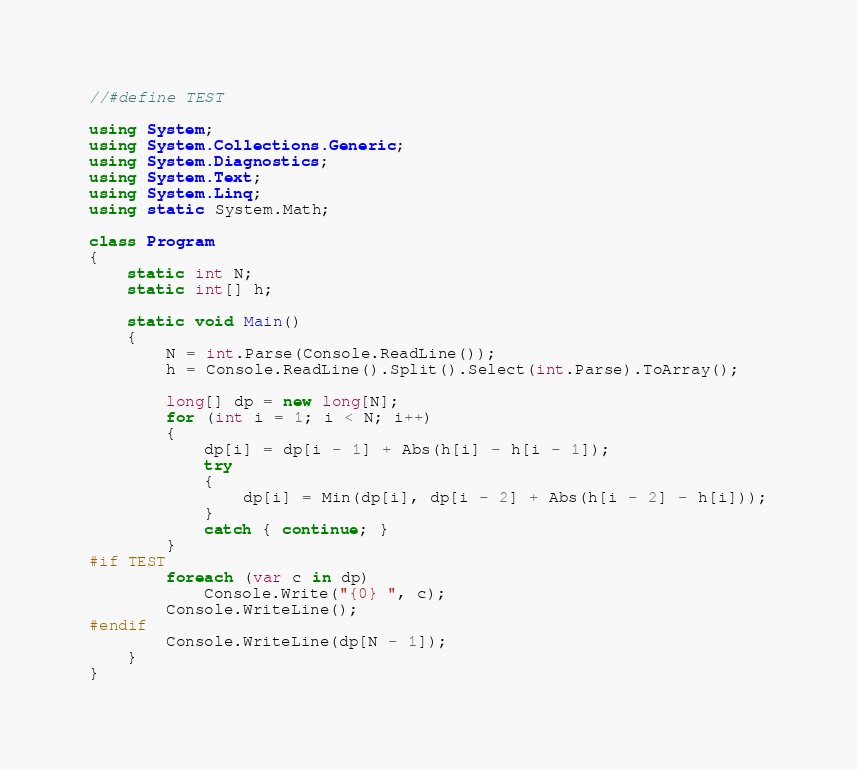<code> <loc_0><loc_0><loc_500><loc_500><_C#_>//#define TEST
 
using System;
using System.Collections.Generic;
using System.Diagnostics;
using System.Text;
using System.Linq;
using static System.Math;
 
class Program
{
    static int N;
    static int[] h;
 
    static void Main()
    {
        N = int.Parse(Console.ReadLine());
        h = Console.ReadLine().Split().Select(int.Parse).ToArray();
 
        long[] dp = new long[N];
        for (int i = 1; i < N; i++)
        {
            dp[i] = dp[i - 1] + Abs(h[i] - h[i - 1]);
            try
            {
                dp[i] = Min(dp[i], dp[i - 2] + Abs(h[i - 2] - h[i]));
            }
            catch { continue; }
        }
#if TEST
        foreach (var c in dp)
            Console.Write("{0} ", c);
        Console.WriteLine();
#endif
        Console.WriteLine(dp[N - 1]);
    }
}</code> 